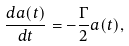Convert formula to latex. <formula><loc_0><loc_0><loc_500><loc_500>\frac { d a ( t ) } { d t } = - \frac { \Gamma } { 2 } a ( t ) ,</formula> 